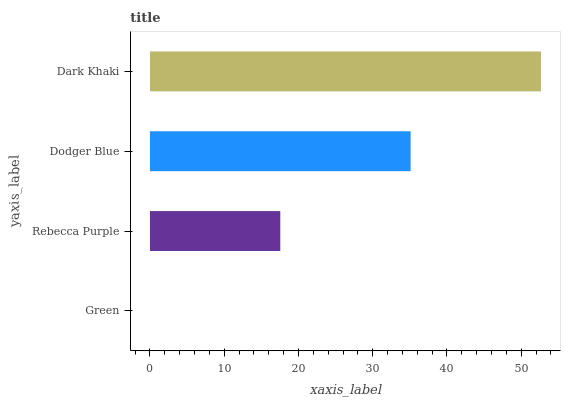Is Green the minimum?
Answer yes or no. Yes. Is Dark Khaki the maximum?
Answer yes or no. Yes. Is Rebecca Purple the minimum?
Answer yes or no. No. Is Rebecca Purple the maximum?
Answer yes or no. No. Is Rebecca Purple greater than Green?
Answer yes or no. Yes. Is Green less than Rebecca Purple?
Answer yes or no. Yes. Is Green greater than Rebecca Purple?
Answer yes or no. No. Is Rebecca Purple less than Green?
Answer yes or no. No. Is Dodger Blue the high median?
Answer yes or no. Yes. Is Rebecca Purple the low median?
Answer yes or no. Yes. Is Green the high median?
Answer yes or no. No. Is Dark Khaki the low median?
Answer yes or no. No. 